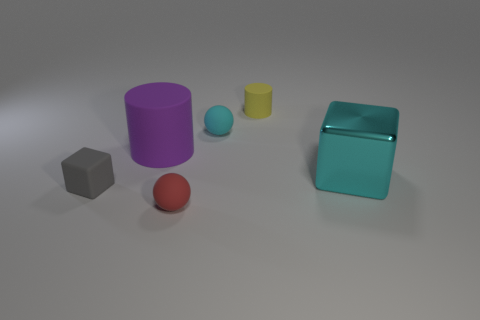Add 3 red spheres. How many objects exist? 9 Subtract all cubes. How many objects are left? 4 Add 4 small matte cubes. How many small matte cubes exist? 5 Subtract 0 brown cylinders. How many objects are left? 6 Subtract all matte blocks. Subtract all cyan cubes. How many objects are left? 4 Add 4 cyan shiny cubes. How many cyan shiny cubes are left? 5 